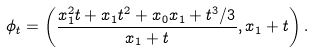<formula> <loc_0><loc_0><loc_500><loc_500>\phi _ { t } = \left ( \frac { x _ { 1 } ^ { 2 } t + x _ { 1 } t ^ { 2 } + x _ { 0 } x _ { 1 } + t ^ { 3 } / 3 } { x _ { 1 } + t } , x _ { 1 } + t \right ) .</formula> 